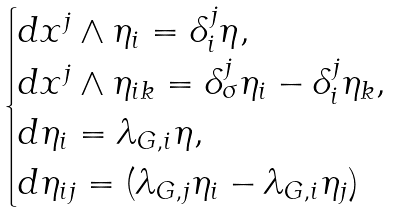Convert formula to latex. <formula><loc_0><loc_0><loc_500><loc_500>\begin{cases} d x ^ { j } \wedge \eta _ { i } = \delta ^ { j } _ { i } \eta , \\ d x ^ { j } \wedge \eta _ { i k } = \delta ^ { j } _ { \sigma } \eta _ { i } - \delta ^ { j } _ { i } \eta _ { k } , \\ d \eta _ { i } = \lambda _ { G , i } \eta , \\ d \eta _ { i j } = ( \lambda _ { G , j } \eta _ { i } - \lambda _ { G , i } \eta _ { j } ) \end{cases}</formula> 